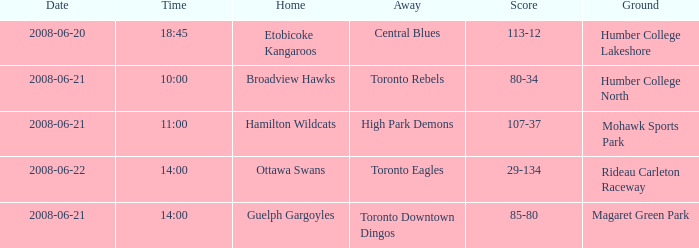What is the Date with a Home that is hamilton wildcats? 2008-06-21. 